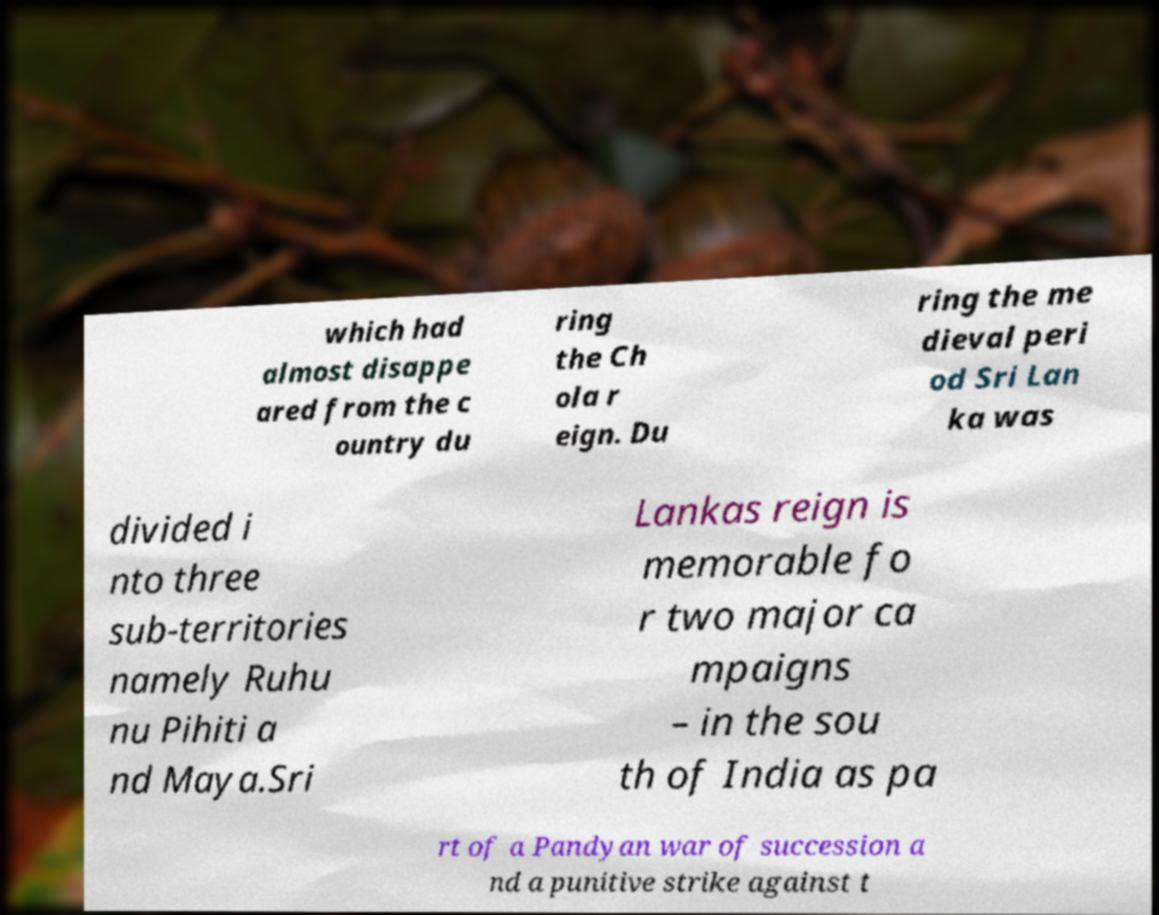For documentation purposes, I need the text within this image transcribed. Could you provide that? which had almost disappe ared from the c ountry du ring the Ch ola r eign. Du ring the me dieval peri od Sri Lan ka was divided i nto three sub-territories namely Ruhu nu Pihiti a nd Maya.Sri Lankas reign is memorable fo r two major ca mpaigns – in the sou th of India as pa rt of a Pandyan war of succession a nd a punitive strike against t 